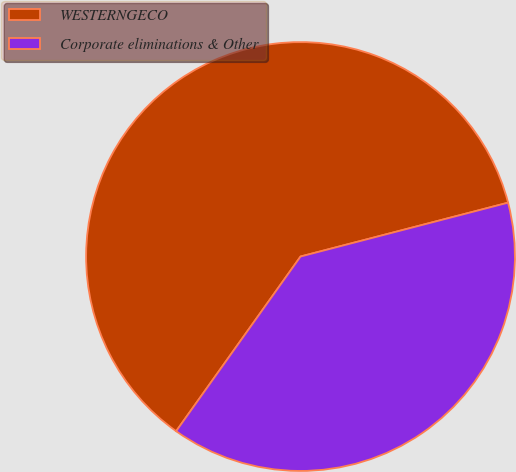Convert chart. <chart><loc_0><loc_0><loc_500><loc_500><pie_chart><fcel>WESTERNGECO<fcel>Corporate eliminations & Other<nl><fcel>61.11%<fcel>38.89%<nl></chart> 